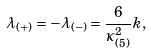Convert formula to latex. <formula><loc_0><loc_0><loc_500><loc_500>\lambda _ { ( + ) } = - \lambda _ { ( - ) } = \frac { 6 } { \kappa _ { ( 5 ) } ^ { 2 } } k ,</formula> 